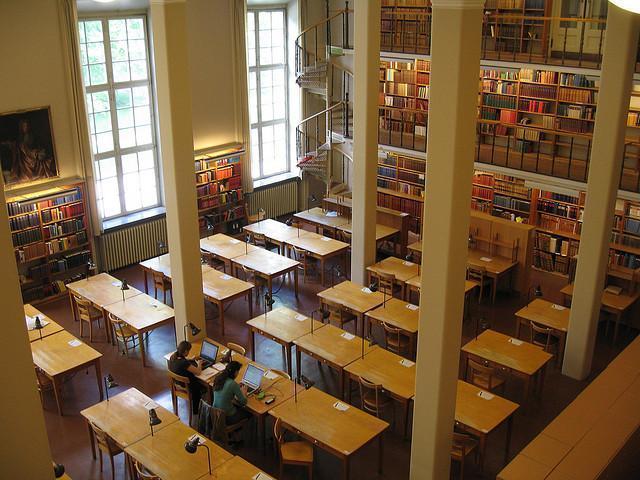What is located in the corner?
Select the accurate response from the four choices given to answer the question.
Options: Trash, couch, stairs, lamp. Stairs. 